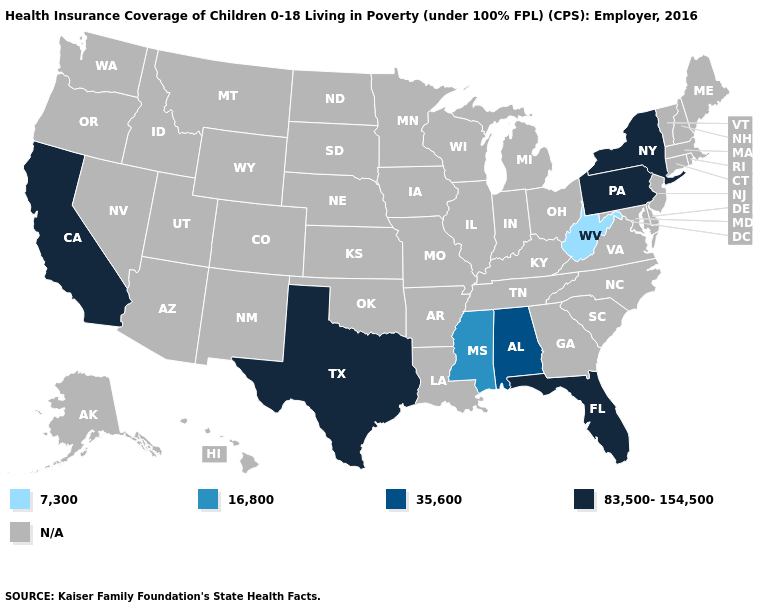Name the states that have a value in the range N/A?
Concise answer only. Alaska, Arizona, Arkansas, Colorado, Connecticut, Delaware, Georgia, Hawaii, Idaho, Illinois, Indiana, Iowa, Kansas, Kentucky, Louisiana, Maine, Maryland, Massachusetts, Michigan, Minnesota, Missouri, Montana, Nebraska, Nevada, New Hampshire, New Jersey, New Mexico, North Carolina, North Dakota, Ohio, Oklahoma, Oregon, Rhode Island, South Carolina, South Dakota, Tennessee, Utah, Vermont, Virginia, Washington, Wisconsin, Wyoming. Does Pennsylvania have the highest value in the USA?
Write a very short answer. Yes. What is the highest value in the Northeast ?
Short answer required. 83,500-154,500. What is the value of Michigan?
Give a very brief answer. N/A. Name the states that have a value in the range 35,600?
Quick response, please. Alabama. Does Pennsylvania have the lowest value in the USA?
Give a very brief answer. No. What is the value of Nevada?
Answer briefly. N/A. Name the states that have a value in the range 83,500-154,500?
Keep it brief. California, Florida, New York, Pennsylvania, Texas. Name the states that have a value in the range N/A?
Concise answer only. Alaska, Arizona, Arkansas, Colorado, Connecticut, Delaware, Georgia, Hawaii, Idaho, Illinois, Indiana, Iowa, Kansas, Kentucky, Louisiana, Maine, Maryland, Massachusetts, Michigan, Minnesota, Missouri, Montana, Nebraska, Nevada, New Hampshire, New Jersey, New Mexico, North Carolina, North Dakota, Ohio, Oklahoma, Oregon, Rhode Island, South Carolina, South Dakota, Tennessee, Utah, Vermont, Virginia, Washington, Wisconsin, Wyoming. What is the value of Oregon?
Give a very brief answer. N/A. Which states hav the highest value in the Northeast?
Keep it brief. New York, Pennsylvania. Name the states that have a value in the range 16,800?
Concise answer only. Mississippi. What is the value of Delaware?
Quick response, please. N/A. Name the states that have a value in the range 7,300?
Be succinct. West Virginia. 